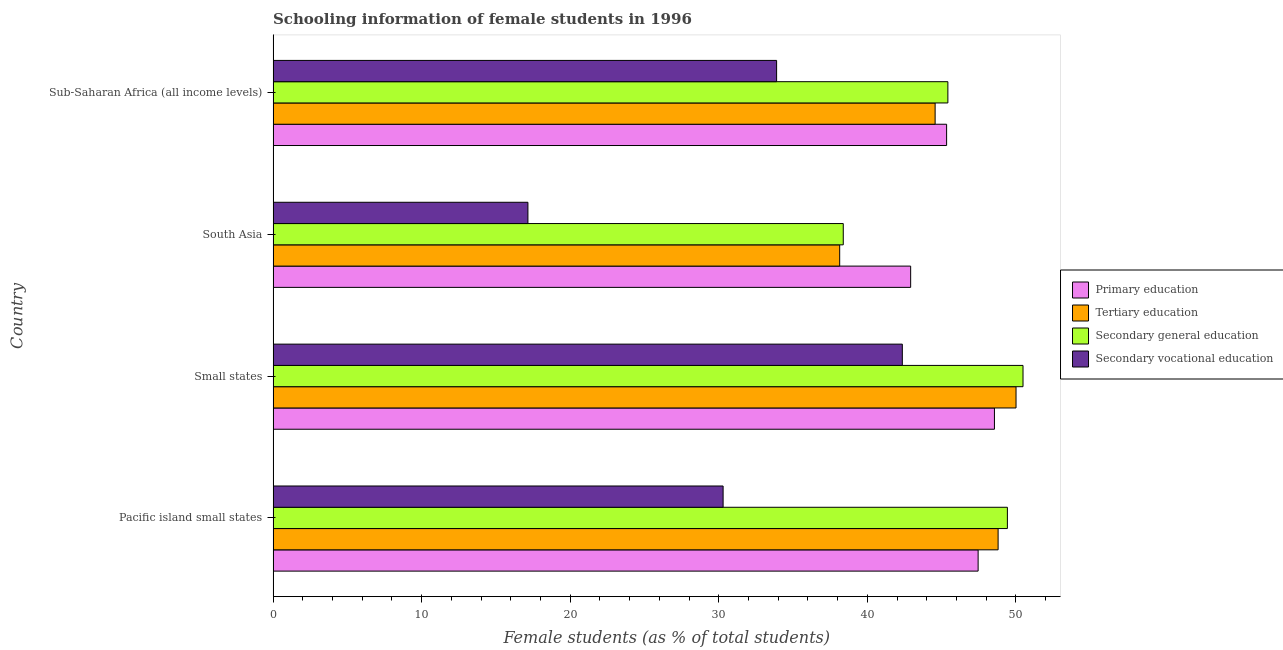How many different coloured bars are there?
Give a very brief answer. 4. Are the number of bars per tick equal to the number of legend labels?
Provide a short and direct response. Yes. Are the number of bars on each tick of the Y-axis equal?
Provide a succinct answer. Yes. How many bars are there on the 1st tick from the bottom?
Keep it short and to the point. 4. What is the label of the 4th group of bars from the top?
Your answer should be compact. Pacific island small states. In how many cases, is the number of bars for a given country not equal to the number of legend labels?
Make the answer very short. 0. What is the percentage of female students in secondary education in South Asia?
Your answer should be very brief. 38.38. Across all countries, what is the maximum percentage of female students in secondary education?
Offer a terse response. 50.48. Across all countries, what is the minimum percentage of female students in secondary vocational education?
Give a very brief answer. 17.15. In which country was the percentage of female students in tertiary education maximum?
Keep it short and to the point. Small states. In which country was the percentage of female students in tertiary education minimum?
Offer a very short reply. South Asia. What is the total percentage of female students in tertiary education in the graph?
Offer a terse response. 181.53. What is the difference between the percentage of female students in secondary vocational education in Pacific island small states and that in South Asia?
Make the answer very short. 13.14. What is the difference between the percentage of female students in secondary education in Pacific island small states and the percentage of female students in secondary vocational education in Sub-Saharan Africa (all income levels)?
Make the answer very short. 15.54. What is the average percentage of female students in tertiary education per country?
Provide a short and direct response. 45.38. What is the difference between the percentage of female students in secondary vocational education and percentage of female students in secondary education in South Asia?
Offer a very short reply. -21.23. In how many countries, is the percentage of female students in tertiary education greater than 40 %?
Your answer should be compact. 3. What is the ratio of the percentage of female students in secondary vocational education in Pacific island small states to that in Small states?
Give a very brief answer. 0.71. Is the percentage of female students in tertiary education in Small states less than that in Sub-Saharan Africa (all income levels)?
Your answer should be very brief. No. What is the difference between the highest and the second highest percentage of female students in secondary education?
Provide a short and direct response. 1.05. What is the difference between the highest and the lowest percentage of female students in tertiary education?
Provide a succinct answer. 11.87. Is the sum of the percentage of female students in primary education in Small states and South Asia greater than the maximum percentage of female students in secondary education across all countries?
Offer a very short reply. Yes. What does the 2nd bar from the top in Pacific island small states represents?
Your response must be concise. Secondary general education. What does the 3rd bar from the bottom in Pacific island small states represents?
Your answer should be compact. Secondary general education. Are all the bars in the graph horizontal?
Keep it short and to the point. Yes. What is the difference between two consecutive major ticks on the X-axis?
Ensure brevity in your answer.  10. How many legend labels are there?
Your response must be concise. 4. How are the legend labels stacked?
Provide a succinct answer. Vertical. What is the title of the graph?
Provide a short and direct response. Schooling information of female students in 1996. Does "Compensation of employees" appear as one of the legend labels in the graph?
Give a very brief answer. No. What is the label or title of the X-axis?
Keep it short and to the point. Female students (as % of total students). What is the Female students (as % of total students) of Primary education in Pacific island small states?
Keep it short and to the point. 47.46. What is the Female students (as % of total students) in Tertiary education in Pacific island small states?
Your answer should be compact. 48.81. What is the Female students (as % of total students) of Secondary general education in Pacific island small states?
Keep it short and to the point. 49.43. What is the Female students (as % of total students) in Secondary vocational education in Pacific island small states?
Offer a terse response. 30.29. What is the Female students (as % of total students) of Primary education in Small states?
Offer a terse response. 48.56. What is the Female students (as % of total students) in Tertiary education in Small states?
Give a very brief answer. 50.01. What is the Female students (as % of total students) in Secondary general education in Small states?
Offer a terse response. 50.48. What is the Female students (as % of total students) of Secondary vocational education in Small states?
Keep it short and to the point. 42.36. What is the Female students (as % of total students) of Primary education in South Asia?
Offer a terse response. 42.92. What is the Female students (as % of total students) in Tertiary education in South Asia?
Your answer should be compact. 38.14. What is the Female students (as % of total students) in Secondary general education in South Asia?
Offer a terse response. 38.38. What is the Female students (as % of total students) in Secondary vocational education in South Asia?
Offer a terse response. 17.15. What is the Female students (as % of total students) in Primary education in Sub-Saharan Africa (all income levels)?
Your answer should be very brief. 45.34. What is the Female students (as % of total students) of Tertiary education in Sub-Saharan Africa (all income levels)?
Provide a succinct answer. 44.57. What is the Female students (as % of total students) of Secondary general education in Sub-Saharan Africa (all income levels)?
Your response must be concise. 45.43. What is the Female students (as % of total students) in Secondary vocational education in Sub-Saharan Africa (all income levels)?
Offer a very short reply. 33.9. Across all countries, what is the maximum Female students (as % of total students) of Primary education?
Keep it short and to the point. 48.56. Across all countries, what is the maximum Female students (as % of total students) of Tertiary education?
Ensure brevity in your answer.  50.01. Across all countries, what is the maximum Female students (as % of total students) of Secondary general education?
Your response must be concise. 50.48. Across all countries, what is the maximum Female students (as % of total students) in Secondary vocational education?
Offer a terse response. 42.36. Across all countries, what is the minimum Female students (as % of total students) in Primary education?
Ensure brevity in your answer.  42.92. Across all countries, what is the minimum Female students (as % of total students) in Tertiary education?
Keep it short and to the point. 38.14. Across all countries, what is the minimum Female students (as % of total students) in Secondary general education?
Ensure brevity in your answer.  38.38. Across all countries, what is the minimum Female students (as % of total students) in Secondary vocational education?
Ensure brevity in your answer.  17.15. What is the total Female students (as % of total students) of Primary education in the graph?
Offer a very short reply. 184.28. What is the total Female students (as % of total students) in Tertiary education in the graph?
Give a very brief answer. 181.53. What is the total Female students (as % of total students) of Secondary general education in the graph?
Keep it short and to the point. 183.72. What is the total Female students (as % of total students) in Secondary vocational education in the graph?
Ensure brevity in your answer.  123.7. What is the difference between the Female students (as % of total students) of Primary education in Pacific island small states and that in Small states?
Your answer should be very brief. -1.1. What is the difference between the Female students (as % of total students) in Tertiary education in Pacific island small states and that in Small states?
Your response must be concise. -1.21. What is the difference between the Female students (as % of total students) of Secondary general education in Pacific island small states and that in Small states?
Offer a very short reply. -1.05. What is the difference between the Female students (as % of total students) in Secondary vocational education in Pacific island small states and that in Small states?
Your answer should be very brief. -12.07. What is the difference between the Female students (as % of total students) in Primary education in Pacific island small states and that in South Asia?
Offer a terse response. 4.54. What is the difference between the Female students (as % of total students) of Tertiary education in Pacific island small states and that in South Asia?
Make the answer very short. 10.67. What is the difference between the Female students (as % of total students) in Secondary general education in Pacific island small states and that in South Asia?
Your answer should be very brief. 11.05. What is the difference between the Female students (as % of total students) of Secondary vocational education in Pacific island small states and that in South Asia?
Your answer should be compact. 13.14. What is the difference between the Female students (as % of total students) of Primary education in Pacific island small states and that in Sub-Saharan Africa (all income levels)?
Your response must be concise. 2.12. What is the difference between the Female students (as % of total students) in Tertiary education in Pacific island small states and that in Sub-Saharan Africa (all income levels)?
Provide a short and direct response. 4.24. What is the difference between the Female students (as % of total students) in Secondary general education in Pacific island small states and that in Sub-Saharan Africa (all income levels)?
Your answer should be compact. 4.01. What is the difference between the Female students (as % of total students) of Secondary vocational education in Pacific island small states and that in Sub-Saharan Africa (all income levels)?
Provide a short and direct response. -3.6. What is the difference between the Female students (as % of total students) of Primary education in Small states and that in South Asia?
Provide a succinct answer. 5.64. What is the difference between the Female students (as % of total students) in Tertiary education in Small states and that in South Asia?
Your response must be concise. 11.87. What is the difference between the Female students (as % of total students) of Secondary general education in Small states and that in South Asia?
Your answer should be compact. 12.1. What is the difference between the Female students (as % of total students) in Secondary vocational education in Small states and that in South Asia?
Offer a very short reply. 25.21. What is the difference between the Female students (as % of total students) in Primary education in Small states and that in Sub-Saharan Africa (all income levels)?
Give a very brief answer. 3.22. What is the difference between the Female students (as % of total students) of Tertiary education in Small states and that in Sub-Saharan Africa (all income levels)?
Offer a terse response. 5.45. What is the difference between the Female students (as % of total students) of Secondary general education in Small states and that in Sub-Saharan Africa (all income levels)?
Provide a short and direct response. 5.06. What is the difference between the Female students (as % of total students) of Secondary vocational education in Small states and that in Sub-Saharan Africa (all income levels)?
Keep it short and to the point. 8.46. What is the difference between the Female students (as % of total students) of Primary education in South Asia and that in Sub-Saharan Africa (all income levels)?
Make the answer very short. -2.42. What is the difference between the Female students (as % of total students) of Tertiary education in South Asia and that in Sub-Saharan Africa (all income levels)?
Offer a very short reply. -6.43. What is the difference between the Female students (as % of total students) in Secondary general education in South Asia and that in Sub-Saharan Africa (all income levels)?
Keep it short and to the point. -7.04. What is the difference between the Female students (as % of total students) of Secondary vocational education in South Asia and that in Sub-Saharan Africa (all income levels)?
Offer a very short reply. -16.74. What is the difference between the Female students (as % of total students) of Primary education in Pacific island small states and the Female students (as % of total students) of Tertiary education in Small states?
Give a very brief answer. -2.55. What is the difference between the Female students (as % of total students) of Primary education in Pacific island small states and the Female students (as % of total students) of Secondary general education in Small states?
Ensure brevity in your answer.  -3.02. What is the difference between the Female students (as % of total students) in Primary education in Pacific island small states and the Female students (as % of total students) in Secondary vocational education in Small states?
Your answer should be very brief. 5.1. What is the difference between the Female students (as % of total students) in Tertiary education in Pacific island small states and the Female students (as % of total students) in Secondary general education in Small states?
Provide a short and direct response. -1.68. What is the difference between the Female students (as % of total students) of Tertiary education in Pacific island small states and the Female students (as % of total students) of Secondary vocational education in Small states?
Provide a short and direct response. 6.45. What is the difference between the Female students (as % of total students) of Secondary general education in Pacific island small states and the Female students (as % of total students) of Secondary vocational education in Small states?
Offer a terse response. 7.07. What is the difference between the Female students (as % of total students) of Primary education in Pacific island small states and the Female students (as % of total students) of Tertiary education in South Asia?
Make the answer very short. 9.32. What is the difference between the Female students (as % of total students) in Primary education in Pacific island small states and the Female students (as % of total students) in Secondary general education in South Asia?
Your answer should be very brief. 9.08. What is the difference between the Female students (as % of total students) in Primary education in Pacific island small states and the Female students (as % of total students) in Secondary vocational education in South Asia?
Keep it short and to the point. 30.31. What is the difference between the Female students (as % of total students) in Tertiary education in Pacific island small states and the Female students (as % of total students) in Secondary general education in South Asia?
Ensure brevity in your answer.  10.42. What is the difference between the Female students (as % of total students) in Tertiary education in Pacific island small states and the Female students (as % of total students) in Secondary vocational education in South Asia?
Your answer should be very brief. 31.65. What is the difference between the Female students (as % of total students) of Secondary general education in Pacific island small states and the Female students (as % of total students) of Secondary vocational education in South Asia?
Your answer should be very brief. 32.28. What is the difference between the Female students (as % of total students) of Primary education in Pacific island small states and the Female students (as % of total students) of Tertiary education in Sub-Saharan Africa (all income levels)?
Offer a very short reply. 2.89. What is the difference between the Female students (as % of total students) in Primary education in Pacific island small states and the Female students (as % of total students) in Secondary general education in Sub-Saharan Africa (all income levels)?
Offer a very short reply. 2.04. What is the difference between the Female students (as % of total students) of Primary education in Pacific island small states and the Female students (as % of total students) of Secondary vocational education in Sub-Saharan Africa (all income levels)?
Make the answer very short. 13.57. What is the difference between the Female students (as % of total students) in Tertiary education in Pacific island small states and the Female students (as % of total students) in Secondary general education in Sub-Saharan Africa (all income levels)?
Ensure brevity in your answer.  3.38. What is the difference between the Female students (as % of total students) of Tertiary education in Pacific island small states and the Female students (as % of total students) of Secondary vocational education in Sub-Saharan Africa (all income levels)?
Make the answer very short. 14.91. What is the difference between the Female students (as % of total students) of Secondary general education in Pacific island small states and the Female students (as % of total students) of Secondary vocational education in Sub-Saharan Africa (all income levels)?
Your answer should be very brief. 15.54. What is the difference between the Female students (as % of total students) of Primary education in Small states and the Female students (as % of total students) of Tertiary education in South Asia?
Your answer should be very brief. 10.42. What is the difference between the Female students (as % of total students) in Primary education in Small states and the Female students (as % of total students) in Secondary general education in South Asia?
Offer a terse response. 10.18. What is the difference between the Female students (as % of total students) in Primary education in Small states and the Female students (as % of total students) in Secondary vocational education in South Asia?
Keep it short and to the point. 31.41. What is the difference between the Female students (as % of total students) in Tertiary education in Small states and the Female students (as % of total students) in Secondary general education in South Asia?
Give a very brief answer. 11.63. What is the difference between the Female students (as % of total students) of Tertiary education in Small states and the Female students (as % of total students) of Secondary vocational education in South Asia?
Your answer should be very brief. 32.86. What is the difference between the Female students (as % of total students) of Secondary general education in Small states and the Female students (as % of total students) of Secondary vocational education in South Asia?
Offer a terse response. 33.33. What is the difference between the Female students (as % of total students) of Primary education in Small states and the Female students (as % of total students) of Tertiary education in Sub-Saharan Africa (all income levels)?
Offer a very short reply. 3.99. What is the difference between the Female students (as % of total students) of Primary education in Small states and the Female students (as % of total students) of Secondary general education in Sub-Saharan Africa (all income levels)?
Your response must be concise. 3.13. What is the difference between the Female students (as % of total students) of Primary education in Small states and the Female students (as % of total students) of Secondary vocational education in Sub-Saharan Africa (all income levels)?
Provide a succinct answer. 14.66. What is the difference between the Female students (as % of total students) in Tertiary education in Small states and the Female students (as % of total students) in Secondary general education in Sub-Saharan Africa (all income levels)?
Offer a very short reply. 4.59. What is the difference between the Female students (as % of total students) in Tertiary education in Small states and the Female students (as % of total students) in Secondary vocational education in Sub-Saharan Africa (all income levels)?
Keep it short and to the point. 16.12. What is the difference between the Female students (as % of total students) of Secondary general education in Small states and the Female students (as % of total students) of Secondary vocational education in Sub-Saharan Africa (all income levels)?
Offer a very short reply. 16.59. What is the difference between the Female students (as % of total students) in Primary education in South Asia and the Female students (as % of total students) in Tertiary education in Sub-Saharan Africa (all income levels)?
Your response must be concise. -1.65. What is the difference between the Female students (as % of total students) of Primary education in South Asia and the Female students (as % of total students) of Secondary general education in Sub-Saharan Africa (all income levels)?
Make the answer very short. -2.51. What is the difference between the Female students (as % of total students) of Primary education in South Asia and the Female students (as % of total students) of Secondary vocational education in Sub-Saharan Africa (all income levels)?
Provide a short and direct response. 9.02. What is the difference between the Female students (as % of total students) in Tertiary education in South Asia and the Female students (as % of total students) in Secondary general education in Sub-Saharan Africa (all income levels)?
Ensure brevity in your answer.  -7.28. What is the difference between the Female students (as % of total students) of Tertiary education in South Asia and the Female students (as % of total students) of Secondary vocational education in Sub-Saharan Africa (all income levels)?
Provide a short and direct response. 4.25. What is the difference between the Female students (as % of total students) of Secondary general education in South Asia and the Female students (as % of total students) of Secondary vocational education in Sub-Saharan Africa (all income levels)?
Offer a very short reply. 4.49. What is the average Female students (as % of total students) in Primary education per country?
Offer a very short reply. 46.07. What is the average Female students (as % of total students) of Tertiary education per country?
Your answer should be very brief. 45.38. What is the average Female students (as % of total students) of Secondary general education per country?
Make the answer very short. 45.93. What is the average Female students (as % of total students) in Secondary vocational education per country?
Provide a short and direct response. 30.93. What is the difference between the Female students (as % of total students) of Primary education and Female students (as % of total students) of Tertiary education in Pacific island small states?
Keep it short and to the point. -1.35. What is the difference between the Female students (as % of total students) in Primary education and Female students (as % of total students) in Secondary general education in Pacific island small states?
Offer a very short reply. -1.97. What is the difference between the Female students (as % of total students) in Primary education and Female students (as % of total students) in Secondary vocational education in Pacific island small states?
Offer a terse response. 17.17. What is the difference between the Female students (as % of total students) in Tertiary education and Female students (as % of total students) in Secondary general education in Pacific island small states?
Ensure brevity in your answer.  -0.62. What is the difference between the Female students (as % of total students) of Tertiary education and Female students (as % of total students) of Secondary vocational education in Pacific island small states?
Your response must be concise. 18.51. What is the difference between the Female students (as % of total students) in Secondary general education and Female students (as % of total students) in Secondary vocational education in Pacific island small states?
Your response must be concise. 19.14. What is the difference between the Female students (as % of total students) of Primary education and Female students (as % of total students) of Tertiary education in Small states?
Offer a very short reply. -1.45. What is the difference between the Female students (as % of total students) in Primary education and Female students (as % of total students) in Secondary general education in Small states?
Provide a short and direct response. -1.92. What is the difference between the Female students (as % of total students) in Primary education and Female students (as % of total students) in Secondary vocational education in Small states?
Provide a succinct answer. 6.2. What is the difference between the Female students (as % of total students) in Tertiary education and Female students (as % of total students) in Secondary general education in Small states?
Provide a short and direct response. -0.47. What is the difference between the Female students (as % of total students) of Tertiary education and Female students (as % of total students) of Secondary vocational education in Small states?
Your answer should be very brief. 7.65. What is the difference between the Female students (as % of total students) in Secondary general education and Female students (as % of total students) in Secondary vocational education in Small states?
Offer a terse response. 8.12. What is the difference between the Female students (as % of total students) in Primary education and Female students (as % of total students) in Tertiary education in South Asia?
Your response must be concise. 4.78. What is the difference between the Female students (as % of total students) of Primary education and Female students (as % of total students) of Secondary general education in South Asia?
Your answer should be compact. 4.54. What is the difference between the Female students (as % of total students) of Primary education and Female students (as % of total students) of Secondary vocational education in South Asia?
Your answer should be compact. 25.77. What is the difference between the Female students (as % of total students) of Tertiary education and Female students (as % of total students) of Secondary general education in South Asia?
Offer a terse response. -0.24. What is the difference between the Female students (as % of total students) of Tertiary education and Female students (as % of total students) of Secondary vocational education in South Asia?
Offer a terse response. 20.99. What is the difference between the Female students (as % of total students) of Secondary general education and Female students (as % of total students) of Secondary vocational education in South Asia?
Keep it short and to the point. 21.23. What is the difference between the Female students (as % of total students) of Primary education and Female students (as % of total students) of Tertiary education in Sub-Saharan Africa (all income levels)?
Offer a terse response. 0.77. What is the difference between the Female students (as % of total students) of Primary education and Female students (as % of total students) of Secondary general education in Sub-Saharan Africa (all income levels)?
Ensure brevity in your answer.  -0.08. What is the difference between the Female students (as % of total students) of Primary education and Female students (as % of total students) of Secondary vocational education in Sub-Saharan Africa (all income levels)?
Offer a very short reply. 11.44. What is the difference between the Female students (as % of total students) in Tertiary education and Female students (as % of total students) in Secondary general education in Sub-Saharan Africa (all income levels)?
Offer a terse response. -0.86. What is the difference between the Female students (as % of total students) in Tertiary education and Female students (as % of total students) in Secondary vocational education in Sub-Saharan Africa (all income levels)?
Your answer should be very brief. 10.67. What is the difference between the Female students (as % of total students) in Secondary general education and Female students (as % of total students) in Secondary vocational education in Sub-Saharan Africa (all income levels)?
Provide a short and direct response. 11.53. What is the ratio of the Female students (as % of total students) of Primary education in Pacific island small states to that in Small states?
Your response must be concise. 0.98. What is the ratio of the Female students (as % of total students) in Tertiary education in Pacific island small states to that in Small states?
Your response must be concise. 0.98. What is the ratio of the Female students (as % of total students) in Secondary general education in Pacific island small states to that in Small states?
Give a very brief answer. 0.98. What is the ratio of the Female students (as % of total students) of Secondary vocational education in Pacific island small states to that in Small states?
Provide a short and direct response. 0.72. What is the ratio of the Female students (as % of total students) in Primary education in Pacific island small states to that in South Asia?
Offer a very short reply. 1.11. What is the ratio of the Female students (as % of total students) in Tertiary education in Pacific island small states to that in South Asia?
Offer a very short reply. 1.28. What is the ratio of the Female students (as % of total students) in Secondary general education in Pacific island small states to that in South Asia?
Provide a short and direct response. 1.29. What is the ratio of the Female students (as % of total students) in Secondary vocational education in Pacific island small states to that in South Asia?
Your response must be concise. 1.77. What is the ratio of the Female students (as % of total students) in Primary education in Pacific island small states to that in Sub-Saharan Africa (all income levels)?
Your response must be concise. 1.05. What is the ratio of the Female students (as % of total students) in Tertiary education in Pacific island small states to that in Sub-Saharan Africa (all income levels)?
Provide a short and direct response. 1.1. What is the ratio of the Female students (as % of total students) of Secondary general education in Pacific island small states to that in Sub-Saharan Africa (all income levels)?
Your response must be concise. 1.09. What is the ratio of the Female students (as % of total students) of Secondary vocational education in Pacific island small states to that in Sub-Saharan Africa (all income levels)?
Keep it short and to the point. 0.89. What is the ratio of the Female students (as % of total students) in Primary education in Small states to that in South Asia?
Provide a succinct answer. 1.13. What is the ratio of the Female students (as % of total students) of Tertiary education in Small states to that in South Asia?
Offer a very short reply. 1.31. What is the ratio of the Female students (as % of total students) of Secondary general education in Small states to that in South Asia?
Your answer should be very brief. 1.32. What is the ratio of the Female students (as % of total students) in Secondary vocational education in Small states to that in South Asia?
Keep it short and to the point. 2.47. What is the ratio of the Female students (as % of total students) of Primary education in Small states to that in Sub-Saharan Africa (all income levels)?
Offer a terse response. 1.07. What is the ratio of the Female students (as % of total students) of Tertiary education in Small states to that in Sub-Saharan Africa (all income levels)?
Provide a succinct answer. 1.12. What is the ratio of the Female students (as % of total students) in Secondary general education in Small states to that in Sub-Saharan Africa (all income levels)?
Ensure brevity in your answer.  1.11. What is the ratio of the Female students (as % of total students) in Secondary vocational education in Small states to that in Sub-Saharan Africa (all income levels)?
Give a very brief answer. 1.25. What is the ratio of the Female students (as % of total students) in Primary education in South Asia to that in Sub-Saharan Africa (all income levels)?
Give a very brief answer. 0.95. What is the ratio of the Female students (as % of total students) in Tertiary education in South Asia to that in Sub-Saharan Africa (all income levels)?
Make the answer very short. 0.86. What is the ratio of the Female students (as % of total students) in Secondary general education in South Asia to that in Sub-Saharan Africa (all income levels)?
Make the answer very short. 0.84. What is the ratio of the Female students (as % of total students) of Secondary vocational education in South Asia to that in Sub-Saharan Africa (all income levels)?
Provide a short and direct response. 0.51. What is the difference between the highest and the second highest Female students (as % of total students) in Primary education?
Your answer should be very brief. 1.1. What is the difference between the highest and the second highest Female students (as % of total students) in Tertiary education?
Keep it short and to the point. 1.21. What is the difference between the highest and the second highest Female students (as % of total students) of Secondary general education?
Your answer should be very brief. 1.05. What is the difference between the highest and the second highest Female students (as % of total students) of Secondary vocational education?
Offer a terse response. 8.46. What is the difference between the highest and the lowest Female students (as % of total students) of Primary education?
Offer a terse response. 5.64. What is the difference between the highest and the lowest Female students (as % of total students) in Tertiary education?
Provide a short and direct response. 11.87. What is the difference between the highest and the lowest Female students (as % of total students) in Secondary general education?
Ensure brevity in your answer.  12.1. What is the difference between the highest and the lowest Female students (as % of total students) in Secondary vocational education?
Make the answer very short. 25.21. 